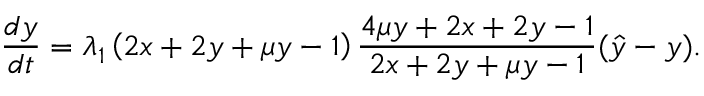Convert formula to latex. <formula><loc_0><loc_0><loc_500><loc_500>\frac { d y } { d t } = \lambda _ { 1 } \left ( 2 x + 2 y + \mu y - 1 \right ) \frac { 4 \mu y + 2 x + 2 y - 1 } { 2 x + 2 y + \mu y - 1 } ( \hat { y } - y ) .</formula> 